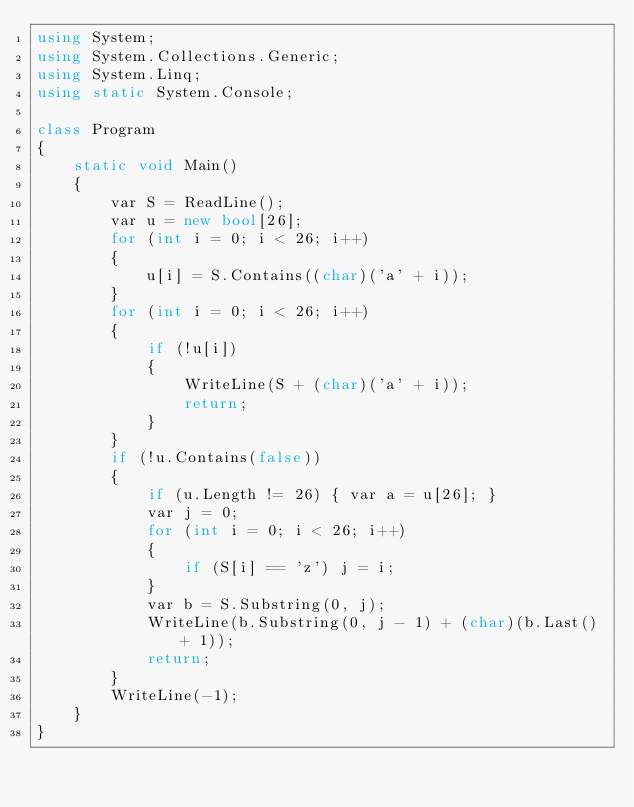<code> <loc_0><loc_0><loc_500><loc_500><_C#_>using System;
using System.Collections.Generic;
using System.Linq;
using static System.Console;

class Program
{
    static void Main()
    {
        var S = ReadLine();
        var u = new bool[26];
        for (int i = 0; i < 26; i++)
        {
            u[i] = S.Contains((char)('a' + i));
        }
        for (int i = 0; i < 26; i++)
        {
            if (!u[i])
            {
                WriteLine(S + (char)('a' + i));
                return;
            }
        }
        if (!u.Contains(false))
        {
            if (u.Length != 26) { var a = u[26]; }
            var j = 0;
            for (int i = 0; i < 26; i++)
            {
                if (S[i] == 'z') j = i;
            }
            var b = S.Substring(0, j);
            WriteLine(b.Substring(0, j - 1) + (char)(b.Last() + 1));
            return;
        }
        WriteLine(-1);
    }
}</code> 